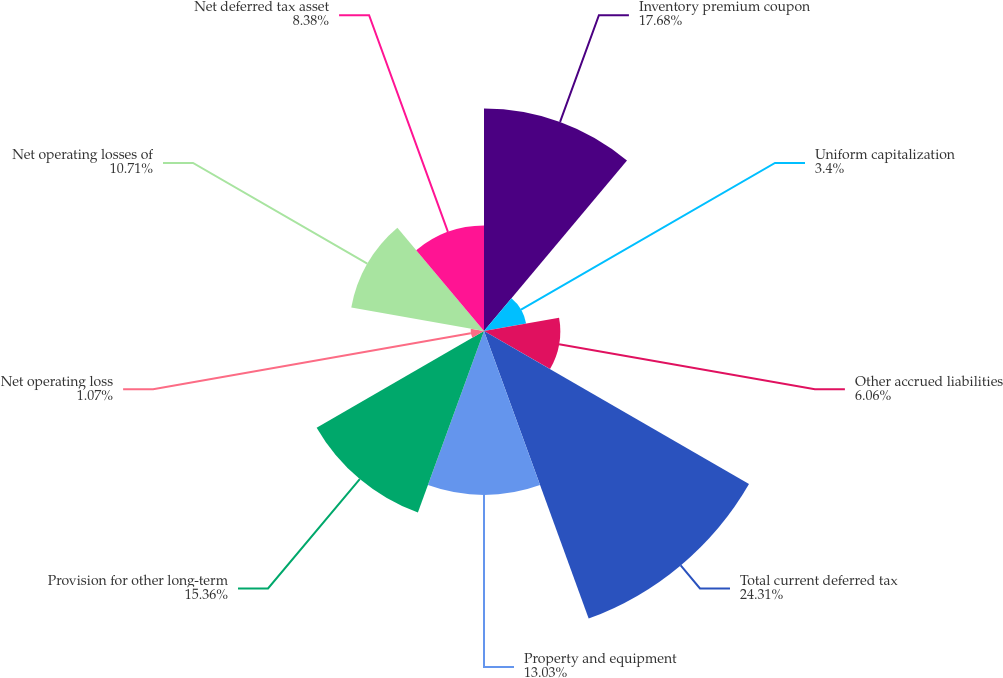Convert chart to OTSL. <chart><loc_0><loc_0><loc_500><loc_500><pie_chart><fcel>Inventory premium coupon<fcel>Uniform capitalization<fcel>Other accrued liabilities<fcel>Total current deferred tax<fcel>Property and equipment<fcel>Provision for other long-term<fcel>Net operating loss<fcel>Net operating losses of<fcel>Net deferred tax asset<nl><fcel>17.68%<fcel>3.4%<fcel>6.06%<fcel>24.32%<fcel>13.03%<fcel>15.36%<fcel>1.07%<fcel>10.71%<fcel>8.38%<nl></chart> 